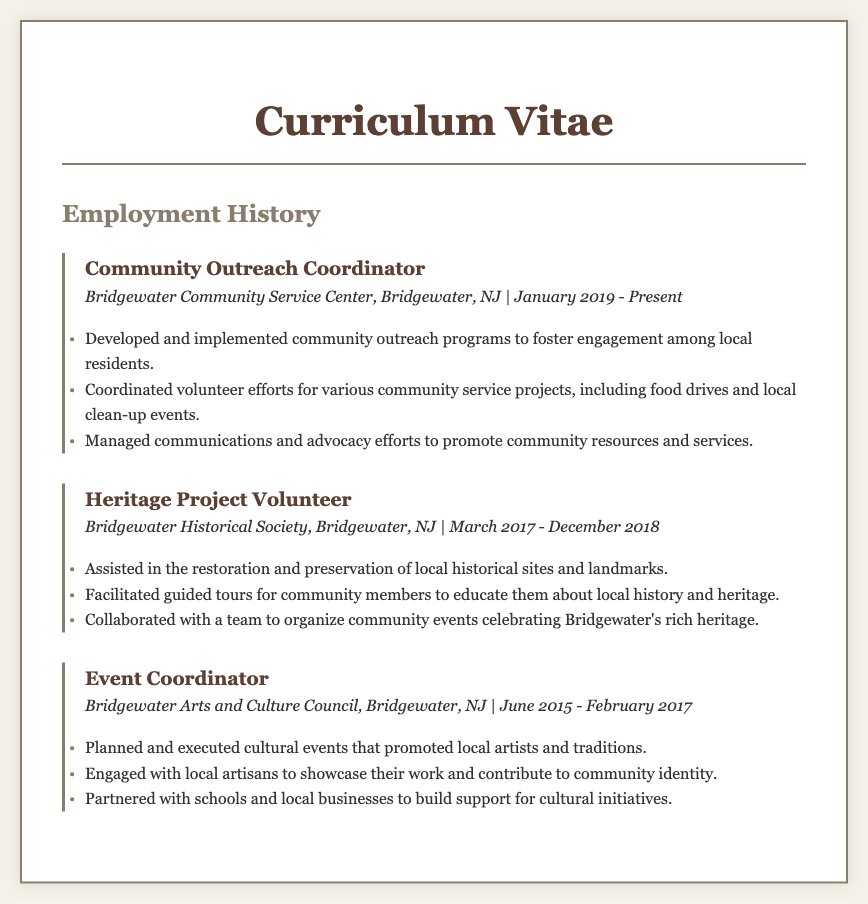What is the current position held? The document lists the current employment as a Community Outreach Coordinator at the Bridgewater Community Service Center.
Answer: Community Outreach Coordinator In which organization did the individual volunteer for heritage projects? The document specifies the individual volunteered at the Bridgewater Historical Society for heritage projects.
Answer: Bridgewater Historical Society What is the start date of the current position? The Curriculum Vitae states the individual started the Community Outreach Coordinator role in January 2019.
Answer: January 2019 How long did the individual serve as an Event Coordinator? The document indicates the individual worked as an Event Coordinator from June 2015 to February 2017, totaling approximately 1 year and 8 months.
Answer: 1 year and 8 months What was one of the primary responsibilities of the Community Outreach Coordinator? The document mentions developing and implementing community outreach programs as a key responsibility of the Community Outreach Coordinator.
Answer: Develop outreach programs Which role involved facilitating guided tours? The document reflects that the Heritage Project Volunteer role included facilitating guided tours for community members.
Answer: Heritage Project Volunteer What kind of events did the Event Coordinator plan? According to the Curriculum Vitae, the Event Coordinator planned cultural events that promoted local artists and traditions.
Answer: Cultural events What type of organization is the Bridgewater Arts and Culture Council? The document describes the organization as focused on arts and culture within the Bridgewater community, specifically involved in cultural initiatives.
Answer: Cultural organization 